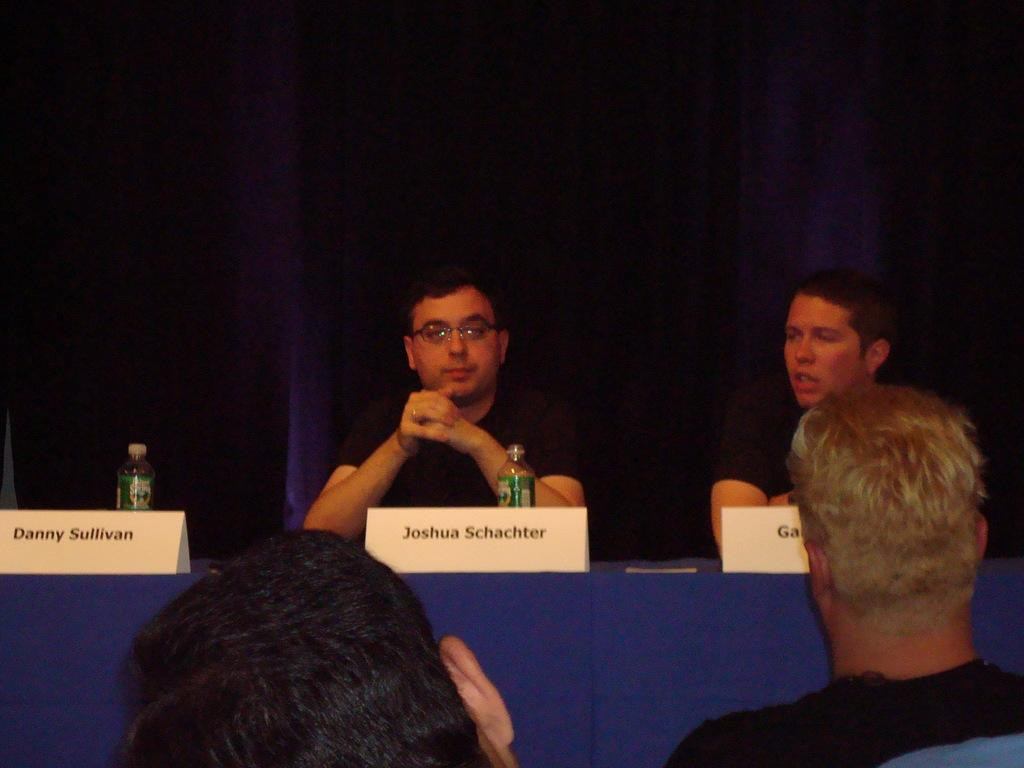How many people are present in the image? There are four people in the image. What are the people doing in the image? The people are sitting in front of a table. What can be seen on the table? There are name plates and bottles on the table. What type of alley can be seen behind the persons in the image? There is no alley visible in the image; it only shows the people sitting in front of a table. What religion do the persons in the image practice? There is no information about the religion of the persons in the image. 